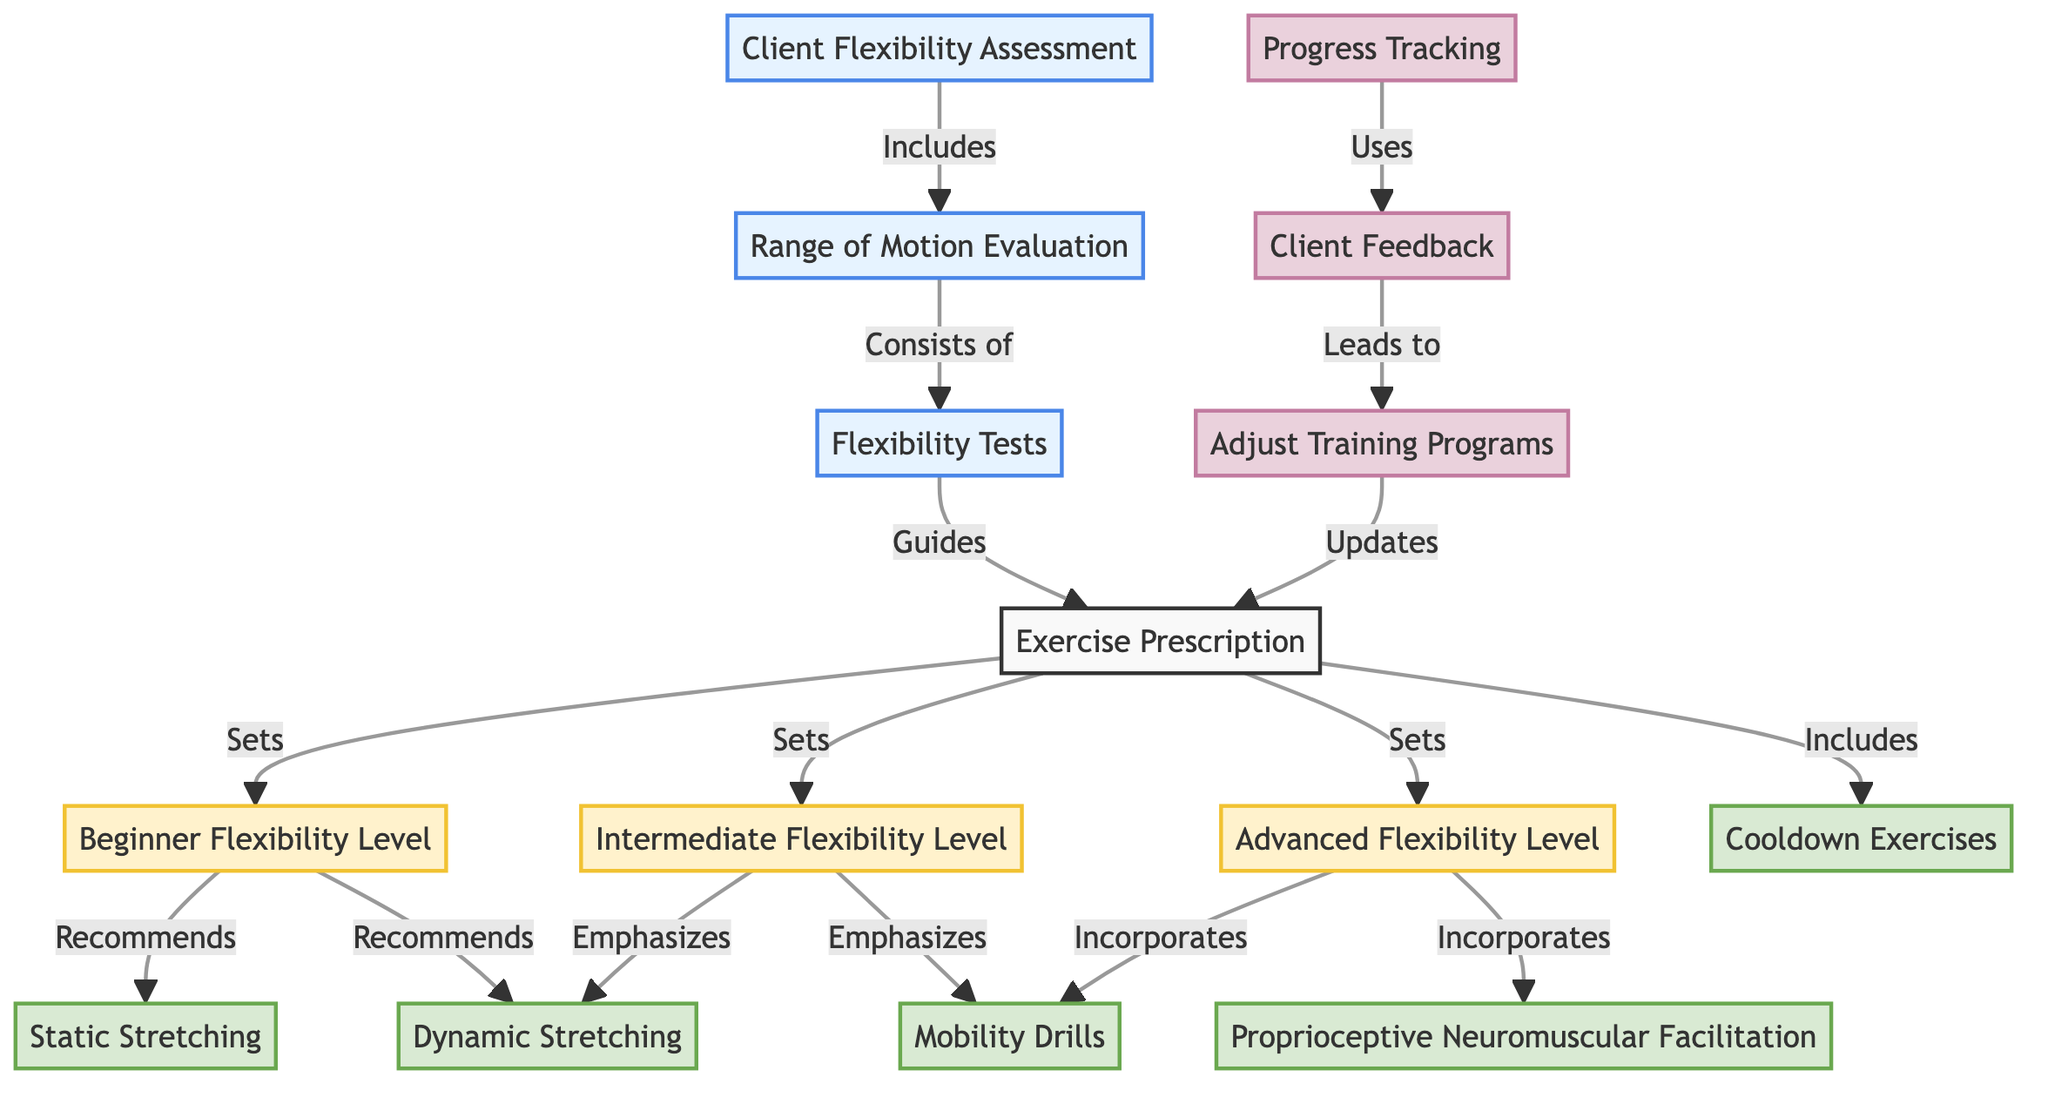What is the starting point of the diagram? The starting point is "Client Flexibility Assessment," as it is the first node that connects to others in the flow.
Answer: Client Flexibility Assessment How many exercise types are recommended for beginner flexibility? There are two exercise types recommended: static stretching and dynamic stretching, both of which are connected to the beginner flexibility node.
Answer: 2 Which level emphasizes dynamic stretching? The intermediate flexibility level emphasizes dynamic stretching, as indicated by the connection from the intermediate flexibility node to the dynamic stretching node.
Answer: Intermediate Flexibility Level What action does client feedback lead to? Client feedback leads to the adjustment of training programs, which is indicated by the directed edge from "Client Feedback" to "Adjust Training Programs."
Answer: Adjust Training Programs How many total nodes are there in the diagram? To find the total number of nodes, we count each unique node in the diagram: 15.
Answer: 15 Which flexibility level incorporates proprioceptive neuromuscular facilitation? The advanced flexibility level incorporates proprioceptive neuromuscular facilitation, as shown by the connection from the advanced flexibility node to the pnf stretching node.
Answer: Advanced Flexibility Level What type of evaluations are included in the client flexibility assessment? The client flexibility assessment includes "Range of Motion Evaluation," which is the direct following node in the diagram.
Answer: Range of Motion Evaluation How does progress tracking relate to exercise prescription? Progress tracking does not connect directly to exercise prescription; instead, it uses client feedback, which in turn leads to the adjustment of training programs that updates the exercise prescription.
Answer: Adjust Training Programs What is the outcome of flexibility tests? Flexibility tests guide the exercise prescription, as indicated by the directed edge from "Flexibility Tests" to "Exercise Prescription."
Answer: Exercise Prescription 